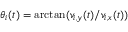<formula> <loc_0><loc_0><loc_500><loc_500>\theta _ { i } ( t ) = \arctan ( v _ { i , y } ( t ) / v _ { i , x } ( t ) )</formula> 